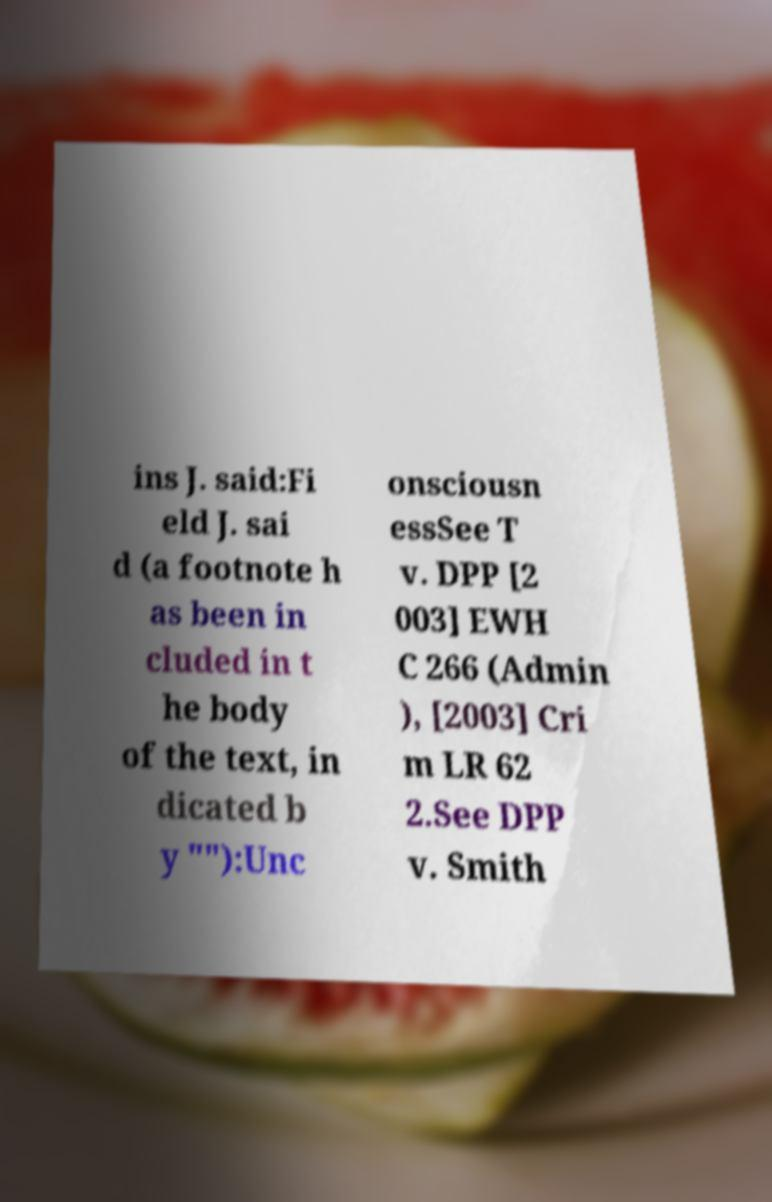I need the written content from this picture converted into text. Can you do that? ins J. said:Fi eld J. sai d (a footnote h as been in cluded in t he body of the text, in dicated b y ""):Unc onsciousn essSee T v. DPP [2 003] EWH C 266 (Admin ), [2003] Cri m LR 62 2.See DPP v. Smith 